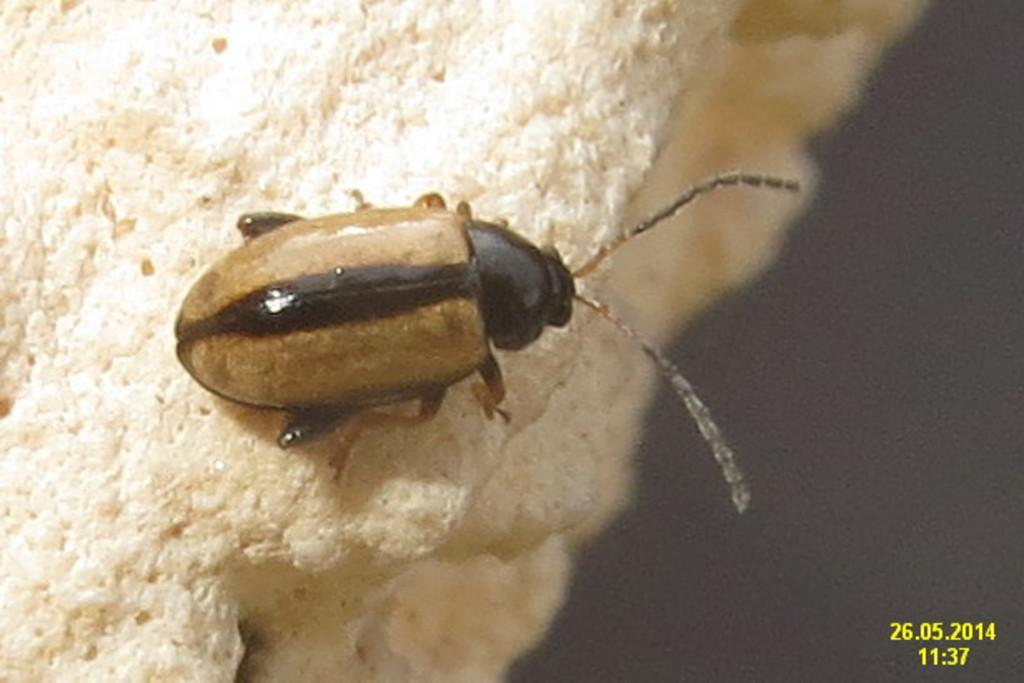What is the main subject of the image? There is an insect in the middle of the image. Can you describe the text in the image? There is some text in the bottom right-hand corner of the image. What type of suit is the insect wearing in the image? There is no suit present in the image, as it features an insect and text. How many rings can be seen on the insect's fingers in the image? There are no rings or fingers present in the image, as it features an insect and text. 